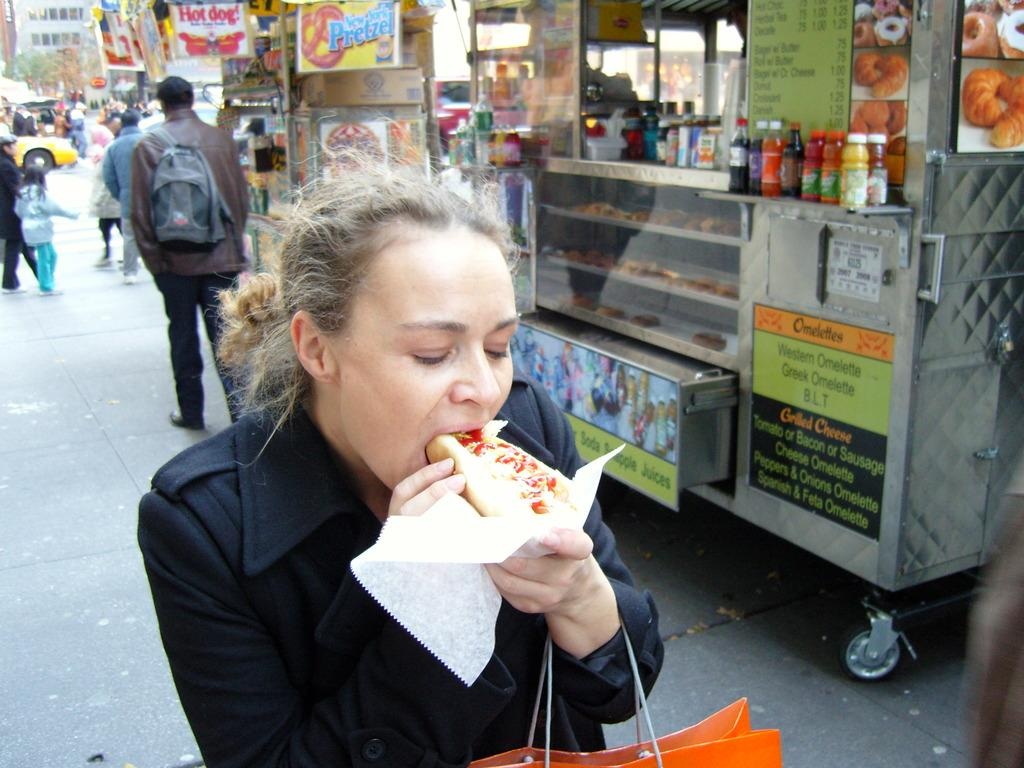<image>
Create a compact narrative representing the image presented. A woman eating a hotdog next to a vendor selling omelettes 